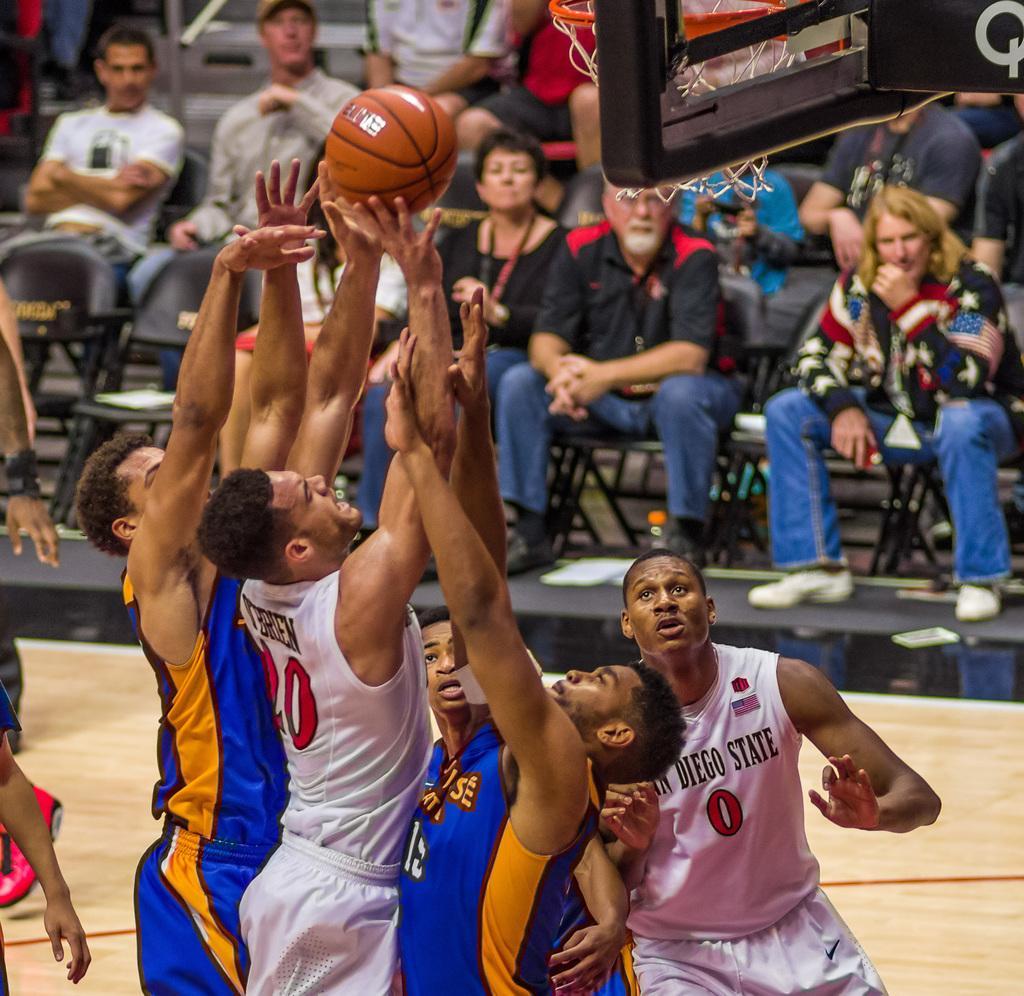In one or two sentences, can you explain what this image depicts? In this image we can see a few people, among them some are playing the basketball and some are sitting on the chairs. 